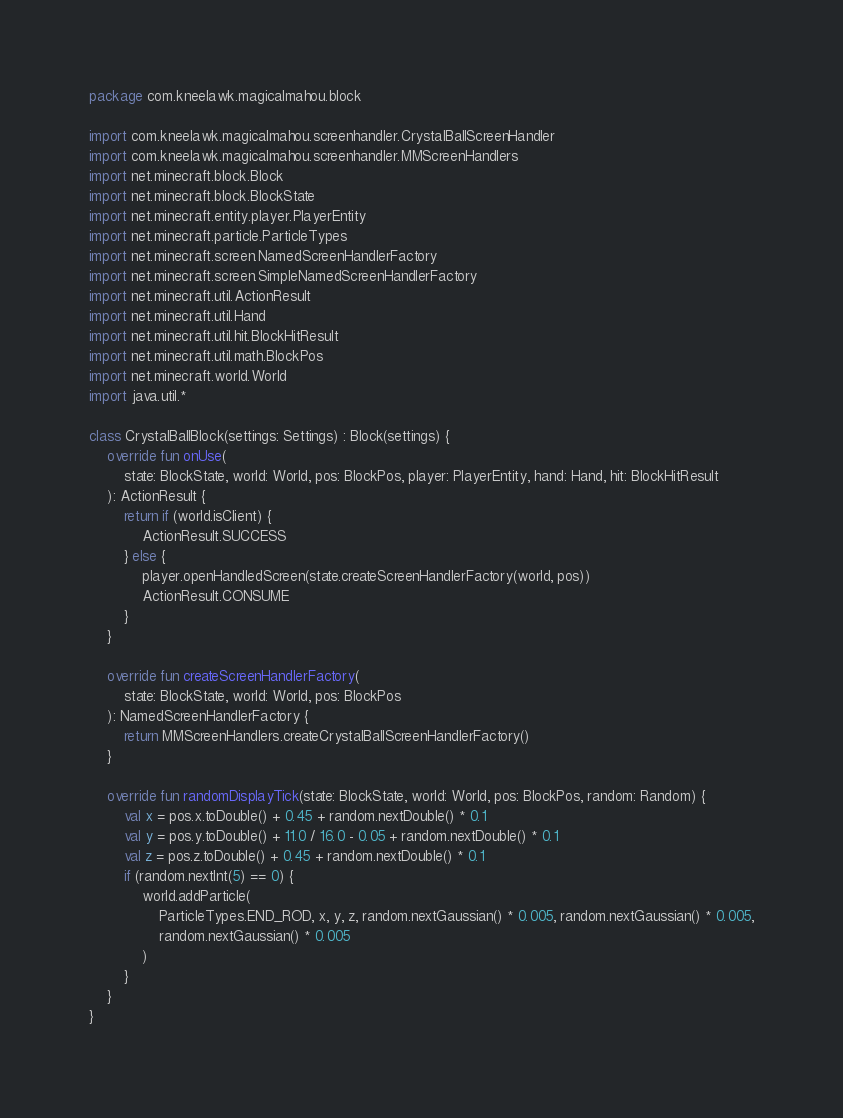<code> <loc_0><loc_0><loc_500><loc_500><_Kotlin_>package com.kneelawk.magicalmahou.block

import com.kneelawk.magicalmahou.screenhandler.CrystalBallScreenHandler
import com.kneelawk.magicalmahou.screenhandler.MMScreenHandlers
import net.minecraft.block.Block
import net.minecraft.block.BlockState
import net.minecraft.entity.player.PlayerEntity
import net.minecraft.particle.ParticleTypes
import net.minecraft.screen.NamedScreenHandlerFactory
import net.minecraft.screen.SimpleNamedScreenHandlerFactory
import net.minecraft.util.ActionResult
import net.minecraft.util.Hand
import net.minecraft.util.hit.BlockHitResult
import net.minecraft.util.math.BlockPos
import net.minecraft.world.World
import java.util.*

class CrystalBallBlock(settings: Settings) : Block(settings) {
    override fun onUse(
        state: BlockState, world: World, pos: BlockPos, player: PlayerEntity, hand: Hand, hit: BlockHitResult
    ): ActionResult {
        return if (world.isClient) {
            ActionResult.SUCCESS
        } else {
            player.openHandledScreen(state.createScreenHandlerFactory(world, pos))
            ActionResult.CONSUME
        }
    }

    override fun createScreenHandlerFactory(
        state: BlockState, world: World, pos: BlockPos
    ): NamedScreenHandlerFactory {
        return MMScreenHandlers.createCrystalBallScreenHandlerFactory()
    }

    override fun randomDisplayTick(state: BlockState, world: World, pos: BlockPos, random: Random) {
        val x = pos.x.toDouble() + 0.45 + random.nextDouble() * 0.1
        val y = pos.y.toDouble() + 11.0 / 16.0 - 0.05 + random.nextDouble() * 0.1
        val z = pos.z.toDouble() + 0.45 + random.nextDouble() * 0.1
        if (random.nextInt(5) == 0) {
            world.addParticle(
                ParticleTypes.END_ROD, x, y, z, random.nextGaussian() * 0.005, random.nextGaussian() * 0.005,
                random.nextGaussian() * 0.005
            )
        }
    }
}</code> 